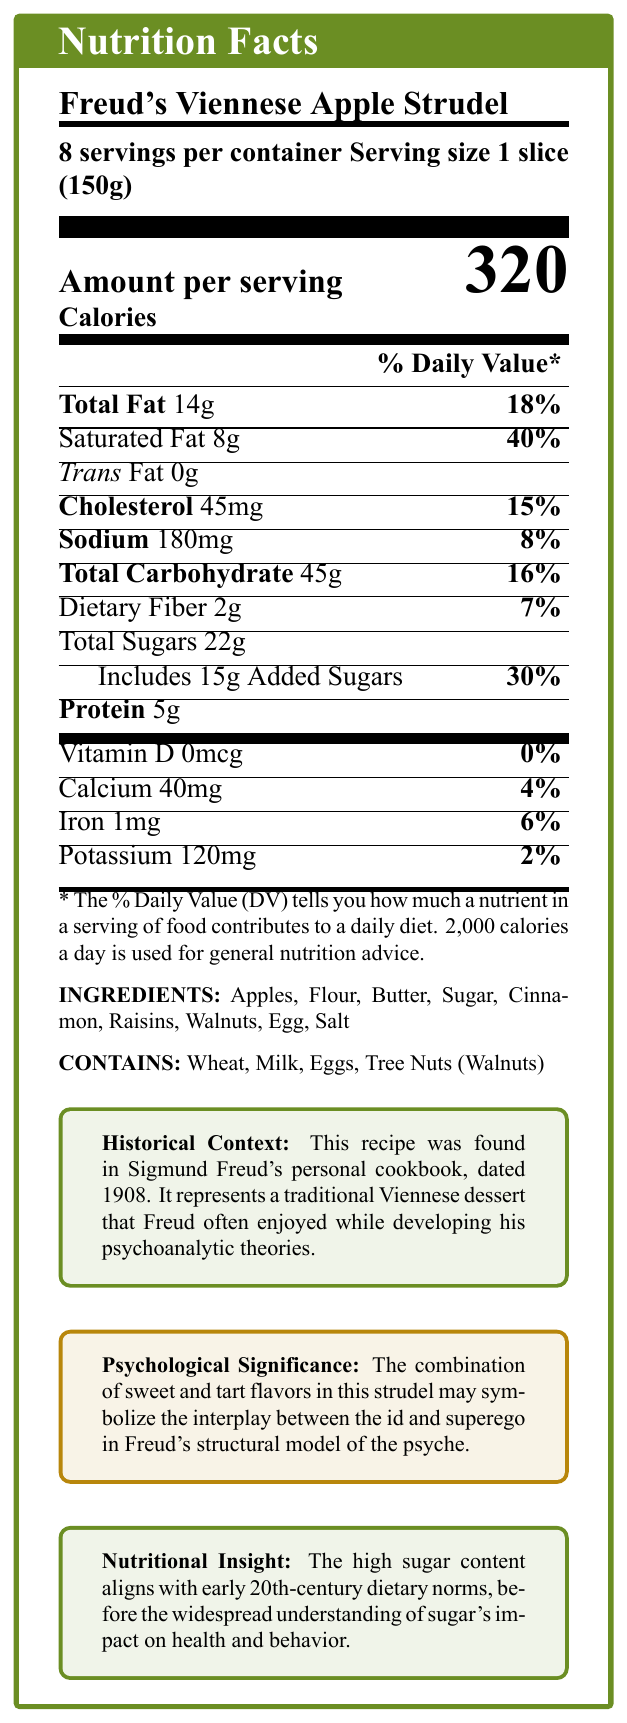What is the serving size for Freud's Viennese Apple Strudel? The document clearly states the serving size as "1 slice (150g)."
Answer: 1 slice (150g) How many servings are there per container? The label specifies that there are 8 servings per container.
Answer: 8 How many calories are in one slice of the apple strudel? The label indicates that one slice contains 320 calories.
Answer: 320 What is the total fat content per serving? The document lists the total fat content per serving as 14 grams.
Answer: 14g How much sodium does each serving contain, and what is its daily value percentage? The sodium content per serving is 180mg, which is 8% of the daily value.
Answer: 180mg, 8% Which of the following ingredients is not listed in the apple strudel? A. Raisins B. Walnuts C. Chocolate The ingredients listed are Apples, Flour, Butter, Sugar, Cinnamon, Raisins, Walnuts, Egg, Salt. Chocolate is not mentioned.
Answer: C. Chocolate What percentage of daily value does the saturated fat contribute per serving? The label indicates that the saturated fat per serving contributes 40% to the daily value.
Answer: 40% Is there any trans fat in the strudel? The document mentions that the trans fat amount is 0 grams.
Answer: No What are the allergens present in the apple strudel? The label clearly states: "Contains: Wheat, Milk, Eggs, Tree Nuts (Walnuts)."
Answer: Wheat, Milk, Eggs, Tree Nuts (Walnuts) What is the total carbohydrate content per serving, and what percentage does it represent of the daily value? The total carbohydrate content per serving is 45 grams, representing 16% of the daily value.
Answer: 45g, 16% Choose the correct amount of dietary fiber present in the strudel per serving: A. 1g B. 2g C. 3g D. 5g The document states that the dietary fiber content per serving is 2 grams.
Answer: B. 2g Does the apple strudel contain any protein? The label indicates that each serving contains 5 grams of protein.
Answer: Yes, 5g Summarize the main idea of the document. The document details the nutritional content per serving, lists ingredients and allergens, and provides contextual information about the recipe's historical and psychological background.
Answer: The document provides the nutritional facts label for Freud's Viennese Apple Strudel, including serving size, calories, and nutrient content. It also highlights historical context, psychological significance, and nutritional insight about the recipe. What is the historical context of Freud's apple strudel recipe? The document provides a box stating that the recipe is from Freud's 1908 cookbook and ties the dessert to his era and work.
Answer: The recipe was found in Sigmund Freud's personal cookbook, dated 1908, representing a traditional Viennese dessert Freud enjoyed while developing his psychoanalytic theories. How does the sugar content in the recipe reflect early 20th-century dietary norms? The document explains that the high sugar content was typical for the period before sugar's health effects were well understood.
Answer: The high sugar content aligns with early 20th-century dietary norms before the widespread understanding of sugar's impact on health and behavior. Does Freud's Viennese Apple Strudel contain any vitamin D? The label shows that the vitamin D content is 0mcg, contributing 0% of the daily value.
Answer: No, 0% What might the combination of sweet and tart flavors in this strudel symbolize according to the document? The document suggests that the sweet and tart flavors symbolize the interaction between the id and superego in Freud's theory.
Answer: The interplay between the id and superego in Freud's structural model of the psyche. What is the amount and daily value percentage of cholesterol in each serving? Each serving contains 45mg of cholesterol, which is 15% of the daily value.
Answer: 45mg, 15% What is the nutritional significance mentioned in the document? The document notes that the high sugar content aligns with dietary norms before the widespread understanding of sugar's health impacts.
Answer: It highlights the high sugar content, reflecting early 20th-century dietary norms. Where did Freud's Viennese Apple Strudel recipe originate? The document states it was found in Freud's cookbook but does not indicate the original source or creator of the recipe.
Answer: Cannot be determined 